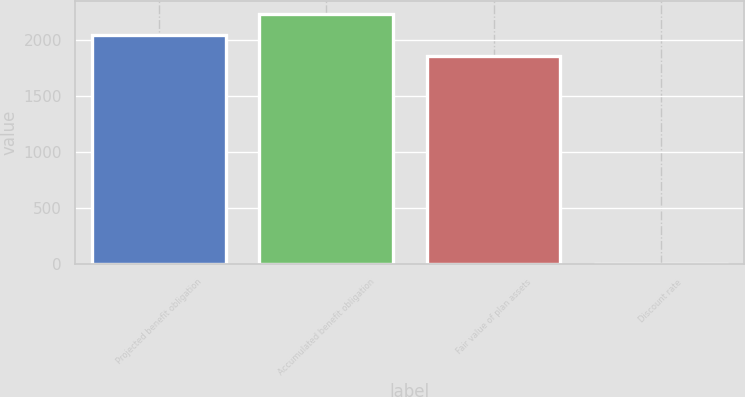Convert chart. <chart><loc_0><loc_0><loc_500><loc_500><bar_chart><fcel>Projected benefit obligation<fcel>Accumulated benefit obligation<fcel>Fair value of plan assets<fcel>Discount rate<nl><fcel>2050.78<fcel>2238.56<fcel>1863<fcel>5.25<nl></chart> 